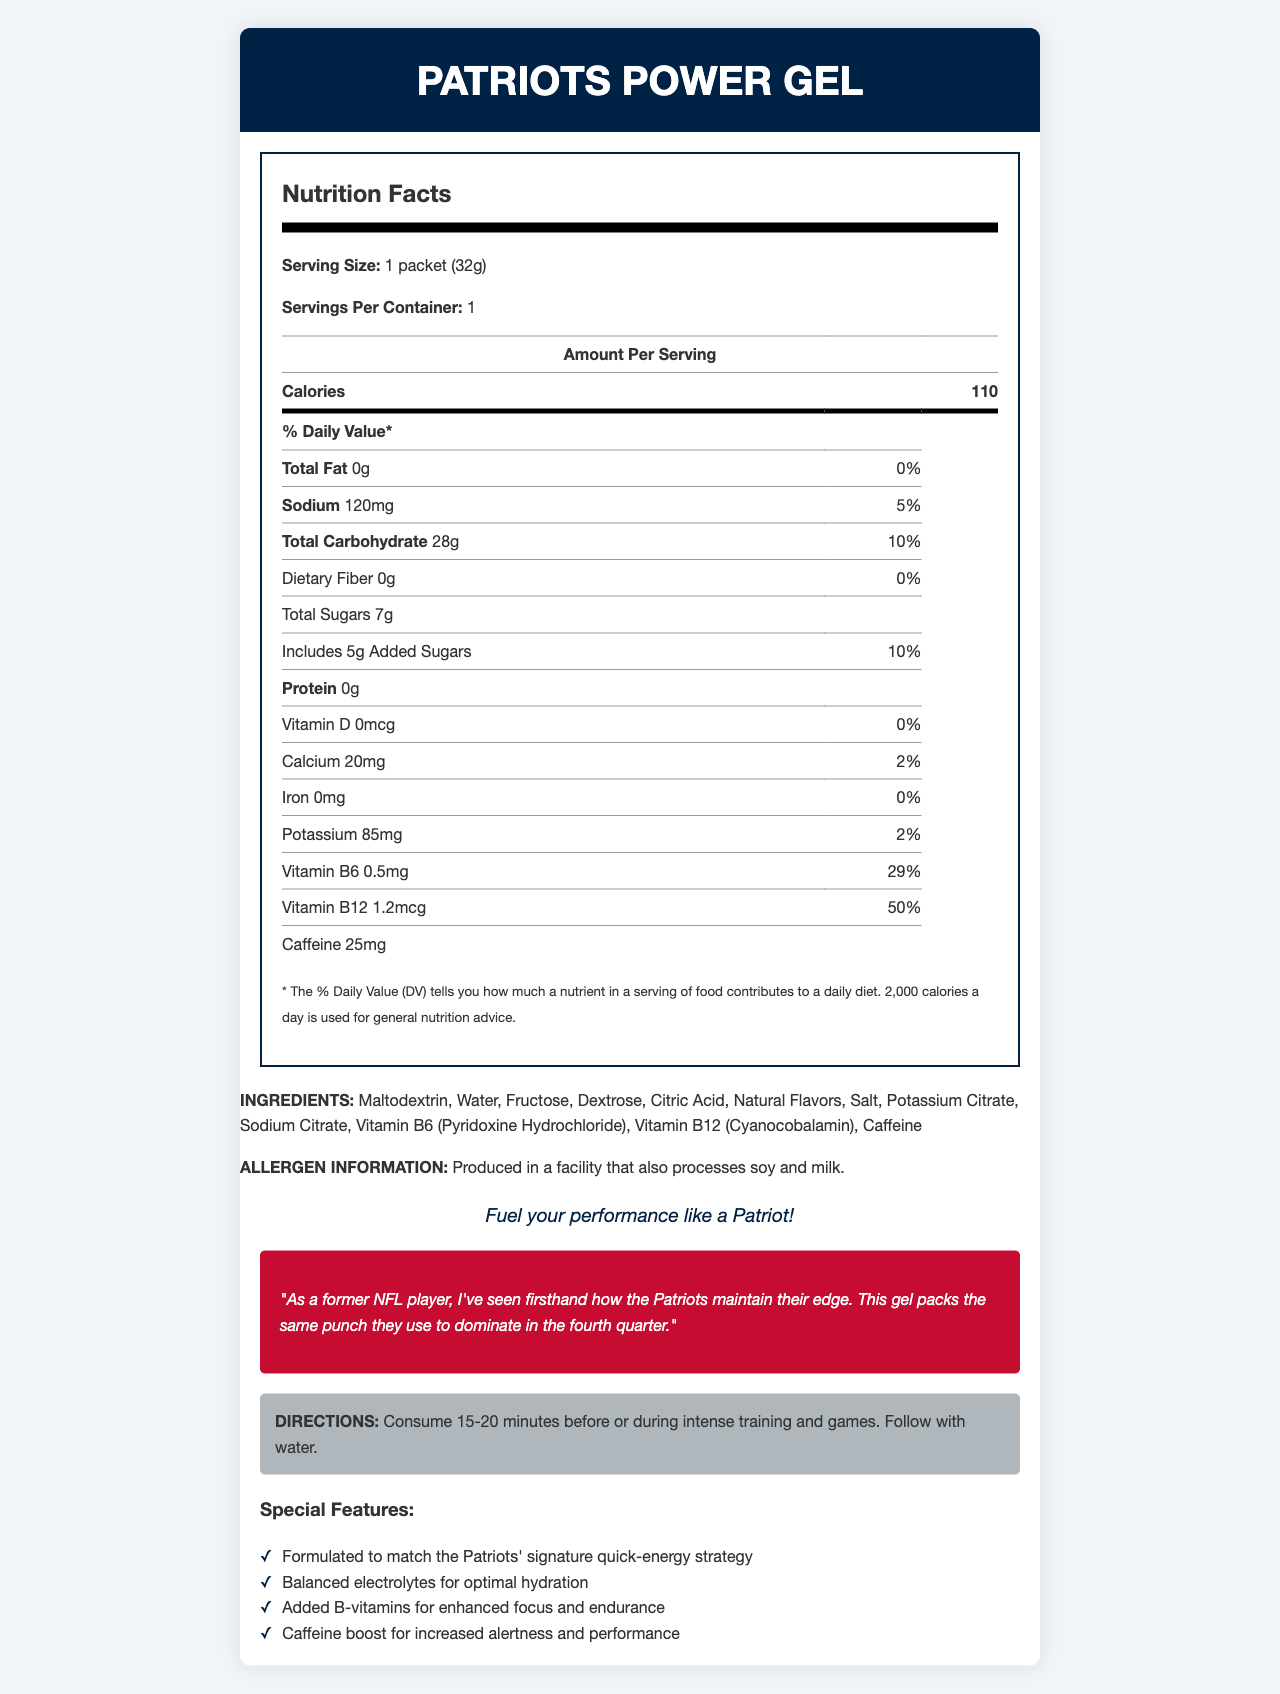what is the serving size for the Patriots Power Gel? The serving size is explicitly mentioned under the Nutrition Facts section as "1 packet (32g)".
Answer: 1 packet (32g) how many calories are in one serving of the Patriots Power Gel? The number of calories per serving is listed as 110 in the Amount Per Serving section.
Answer: 110 what is the percentage of daily value for sodium in Patriots Power Gel? The document states that the daily value percentage for sodium is 5%.
Answer: 5% name two main ingredients in the Patriots Power Gel. The ingredient list mentions "Maltodextrin, Water, Fructose, Dextrose, Citric Acid, Natural Flavors, Salt, Potassium Citrate, Sodium Citrate, Vitamin B6 (Pyridoxine Hydrochloride), Vitamin B12 (Cyanocobalamin), Caffeine".
Answer: Maltodextrin, Fructose how much potassium is there in a serving of Patriots Power Gel? The amount of potassium per serving is listed as 85mg in the nutritional breakdown.
Answer: 85mg which vitamin is present at higher daily value percentage in the Patriots Power Gel? A. Vitamin D B. Calcium C. Vitamin B6 D. Vitamin B12 Vitamin B12 is present at 50%, which is higher compared to Vitamin B6 at 29%, Calcium at 2%, and Vitamin D at 0%.
Answer: D Patriots Power Gel contains added sugars. True or False? It is mentioned in the sub-item under Total Sugars that it includes 5g of Added Sugars.
Answer: True what is the allergen information provided for Patriots Power Gel? The allergen information clearly states that the gel is produced in a facility that also processes soy and milk.
Answer: Produced in a facility that also processes soy and milk. who provided the athlete testimonial in the Patriots Power Gel document? The document states, "As a former NFL player, I've seen firsthand how the Patriots maintain their edge..."
Answer: A retired NFL player how much caffeine is included in the Patriots Power Gel? The caffeine content is clearly listed as 25mg in the nutritional information section.
Answer: 25mg what is the main purpose of the Patriots Power Gel as per the directions? The directions section specifies to consume the gel 15-20 minutes before or during intense training and games.
Answer: To consume 15-20 minutes before or during intense training and games. compare the daily values for vitamin B6 and vitamin D in the Patriots Power Gel. The document lists Vitamin B6 at 29% daily value and Vitamin D at 0%.
Answer: Vitamin B6: 29%, Vitamin D: 0% explain the special features of Patriots Power Gel. These special features are enumerated in the document under the Special Features section.
Answer: Formulated to match the Patriots' signature quick-energy strategy, Balanced electrolytes for optimal hydration, Added B-vitamins for enhanced focus and endurance, Caffeine boost for increased alertness and performance what is the protein content in the Patriots Power Gel? The protein content is clearly listed as 0g in the nutrition facts table.
Answer: 0g does the Patriots Power Gel have any dietary fiber? The dietary fiber content is listed as 0g, indicating there is no dietary fiber.
Answer: No provide a summary of the Patriots Power Gel document. The document combines nutritional information, ingredients, and features to illustrate the benefits and use of the Patriots Power Gel for energy and hydration.
Answer: The Patriots Power Gel document provides detailed nutrition facts, ingredient list, allergen information, brand statement, athlete testimonial, directions for use, and special features of the energy gel. It highlights that the gel contains 110 calories per serving, with a significant focus on quick energy and hydration, supported by ingredients such as maltodextrin, fructose, and added B-vitamins. The presence of electrolytes and caffeine is emphasized for optimal performance during intense training sessions. what is the total carbohydrate content in the Patriots Power Gel? How many grams of that are sugars? The document lists 28g as total carbohydrate content, with 7g coming from sugars.
Answer: Total Carbohydrate: 28g, Total Sugars: 7g how does the Patriots Power Gel assist in focus and endurance? The special features mention that the energy gel has added B-vitamins for enhanced focus and endurance.
Answer: By providing added B-vitamins when should the Patriots Power Gel be consumed for best results? A. In the morning B. Before/during intense training C. After meals D. At bedtime The directions specify that the gel should be consumed 15-20 minutes before or during intense training and games for best results.
Answer: B how does the Patriots Power Gel contribute to the hydration of athletes? The special features list that the gel is formulated with balanced electrolytes to optimize hydration.
Answer: Balanced electrolytes for optimal hydration who manufactures the Patriots Power Gel? The document does not provide information about the manufacturer of the Patriots Power Gel.
Answer: Not enough information 